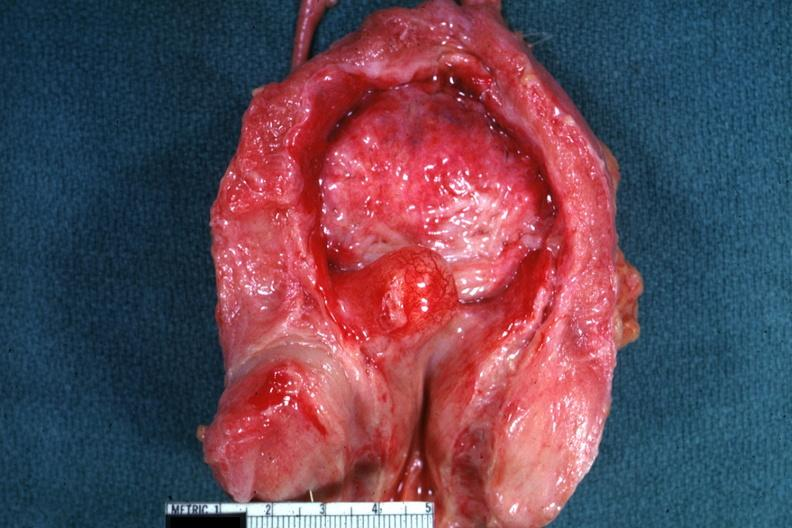what is present?
Answer the question using a single word or phrase. Hyperplasia 